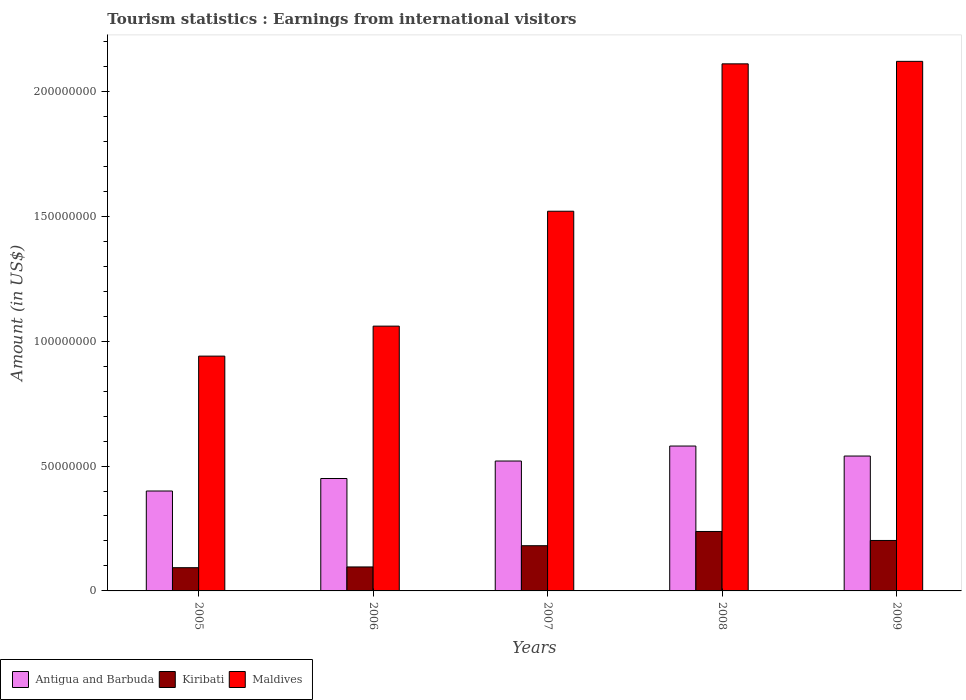How many different coloured bars are there?
Ensure brevity in your answer.  3. How many groups of bars are there?
Provide a short and direct response. 5. Are the number of bars per tick equal to the number of legend labels?
Make the answer very short. Yes. What is the label of the 1st group of bars from the left?
Your answer should be compact. 2005. What is the earnings from international visitors in Kiribati in 2007?
Your answer should be compact. 1.81e+07. Across all years, what is the maximum earnings from international visitors in Maldives?
Offer a terse response. 2.12e+08. Across all years, what is the minimum earnings from international visitors in Kiribati?
Ensure brevity in your answer.  9.30e+06. What is the total earnings from international visitors in Antigua and Barbuda in the graph?
Offer a very short reply. 2.49e+08. What is the difference between the earnings from international visitors in Kiribati in 2005 and that in 2007?
Make the answer very short. -8.80e+06. What is the difference between the earnings from international visitors in Maldives in 2005 and the earnings from international visitors in Antigua and Barbuda in 2006?
Your answer should be very brief. 4.90e+07. What is the average earnings from international visitors in Maldives per year?
Offer a very short reply. 1.55e+08. In the year 2008, what is the difference between the earnings from international visitors in Kiribati and earnings from international visitors in Maldives?
Your response must be concise. -1.87e+08. What is the ratio of the earnings from international visitors in Kiribati in 2005 to that in 2008?
Give a very brief answer. 0.39. What is the difference between the highest and the lowest earnings from international visitors in Maldives?
Provide a succinct answer. 1.18e+08. Is the sum of the earnings from international visitors in Kiribati in 2006 and 2007 greater than the maximum earnings from international visitors in Maldives across all years?
Ensure brevity in your answer.  No. What does the 1st bar from the left in 2005 represents?
Offer a terse response. Antigua and Barbuda. What does the 1st bar from the right in 2009 represents?
Provide a succinct answer. Maldives. Is it the case that in every year, the sum of the earnings from international visitors in Maldives and earnings from international visitors in Kiribati is greater than the earnings from international visitors in Antigua and Barbuda?
Give a very brief answer. Yes. Are all the bars in the graph horizontal?
Offer a terse response. No. What is the difference between two consecutive major ticks on the Y-axis?
Offer a very short reply. 5.00e+07. Where does the legend appear in the graph?
Offer a terse response. Bottom left. How many legend labels are there?
Provide a short and direct response. 3. How are the legend labels stacked?
Offer a very short reply. Horizontal. What is the title of the graph?
Make the answer very short. Tourism statistics : Earnings from international visitors. Does "Liberia" appear as one of the legend labels in the graph?
Keep it short and to the point. No. What is the Amount (in US$) in Antigua and Barbuda in 2005?
Ensure brevity in your answer.  4.00e+07. What is the Amount (in US$) in Kiribati in 2005?
Your answer should be very brief. 9.30e+06. What is the Amount (in US$) in Maldives in 2005?
Keep it short and to the point. 9.40e+07. What is the Amount (in US$) of Antigua and Barbuda in 2006?
Provide a short and direct response. 4.50e+07. What is the Amount (in US$) of Kiribati in 2006?
Your answer should be compact. 9.60e+06. What is the Amount (in US$) of Maldives in 2006?
Your response must be concise. 1.06e+08. What is the Amount (in US$) in Antigua and Barbuda in 2007?
Provide a succinct answer. 5.20e+07. What is the Amount (in US$) in Kiribati in 2007?
Your response must be concise. 1.81e+07. What is the Amount (in US$) of Maldives in 2007?
Provide a succinct answer. 1.52e+08. What is the Amount (in US$) in Antigua and Barbuda in 2008?
Make the answer very short. 5.80e+07. What is the Amount (in US$) in Kiribati in 2008?
Offer a terse response. 2.38e+07. What is the Amount (in US$) in Maldives in 2008?
Ensure brevity in your answer.  2.11e+08. What is the Amount (in US$) in Antigua and Barbuda in 2009?
Your response must be concise. 5.40e+07. What is the Amount (in US$) in Kiribati in 2009?
Offer a very short reply. 2.02e+07. What is the Amount (in US$) in Maldives in 2009?
Make the answer very short. 2.12e+08. Across all years, what is the maximum Amount (in US$) in Antigua and Barbuda?
Offer a terse response. 5.80e+07. Across all years, what is the maximum Amount (in US$) of Kiribati?
Your answer should be compact. 2.38e+07. Across all years, what is the maximum Amount (in US$) in Maldives?
Provide a succinct answer. 2.12e+08. Across all years, what is the minimum Amount (in US$) in Antigua and Barbuda?
Your answer should be compact. 4.00e+07. Across all years, what is the minimum Amount (in US$) in Kiribati?
Your answer should be compact. 9.30e+06. Across all years, what is the minimum Amount (in US$) of Maldives?
Provide a short and direct response. 9.40e+07. What is the total Amount (in US$) in Antigua and Barbuda in the graph?
Provide a short and direct response. 2.49e+08. What is the total Amount (in US$) in Kiribati in the graph?
Provide a succinct answer. 8.10e+07. What is the total Amount (in US$) in Maldives in the graph?
Your response must be concise. 7.75e+08. What is the difference between the Amount (in US$) in Antigua and Barbuda in 2005 and that in 2006?
Your answer should be very brief. -5.00e+06. What is the difference between the Amount (in US$) in Kiribati in 2005 and that in 2006?
Provide a short and direct response. -3.00e+05. What is the difference between the Amount (in US$) in Maldives in 2005 and that in 2006?
Provide a succinct answer. -1.20e+07. What is the difference between the Amount (in US$) in Antigua and Barbuda in 2005 and that in 2007?
Ensure brevity in your answer.  -1.20e+07. What is the difference between the Amount (in US$) of Kiribati in 2005 and that in 2007?
Provide a short and direct response. -8.80e+06. What is the difference between the Amount (in US$) in Maldives in 2005 and that in 2007?
Offer a terse response. -5.80e+07. What is the difference between the Amount (in US$) of Antigua and Barbuda in 2005 and that in 2008?
Your answer should be compact. -1.80e+07. What is the difference between the Amount (in US$) in Kiribati in 2005 and that in 2008?
Provide a succinct answer. -1.45e+07. What is the difference between the Amount (in US$) of Maldives in 2005 and that in 2008?
Your answer should be very brief. -1.17e+08. What is the difference between the Amount (in US$) in Antigua and Barbuda in 2005 and that in 2009?
Give a very brief answer. -1.40e+07. What is the difference between the Amount (in US$) of Kiribati in 2005 and that in 2009?
Make the answer very short. -1.09e+07. What is the difference between the Amount (in US$) of Maldives in 2005 and that in 2009?
Your response must be concise. -1.18e+08. What is the difference between the Amount (in US$) in Antigua and Barbuda in 2006 and that in 2007?
Ensure brevity in your answer.  -7.00e+06. What is the difference between the Amount (in US$) in Kiribati in 2006 and that in 2007?
Your answer should be compact. -8.50e+06. What is the difference between the Amount (in US$) of Maldives in 2006 and that in 2007?
Make the answer very short. -4.60e+07. What is the difference between the Amount (in US$) in Antigua and Barbuda in 2006 and that in 2008?
Your response must be concise. -1.30e+07. What is the difference between the Amount (in US$) in Kiribati in 2006 and that in 2008?
Ensure brevity in your answer.  -1.42e+07. What is the difference between the Amount (in US$) of Maldives in 2006 and that in 2008?
Your answer should be very brief. -1.05e+08. What is the difference between the Amount (in US$) of Antigua and Barbuda in 2006 and that in 2009?
Provide a short and direct response. -9.00e+06. What is the difference between the Amount (in US$) of Kiribati in 2006 and that in 2009?
Make the answer very short. -1.06e+07. What is the difference between the Amount (in US$) of Maldives in 2006 and that in 2009?
Provide a succinct answer. -1.06e+08. What is the difference between the Amount (in US$) in Antigua and Barbuda in 2007 and that in 2008?
Provide a succinct answer. -6.00e+06. What is the difference between the Amount (in US$) of Kiribati in 2007 and that in 2008?
Keep it short and to the point. -5.70e+06. What is the difference between the Amount (in US$) of Maldives in 2007 and that in 2008?
Keep it short and to the point. -5.90e+07. What is the difference between the Amount (in US$) in Kiribati in 2007 and that in 2009?
Your answer should be very brief. -2.10e+06. What is the difference between the Amount (in US$) of Maldives in 2007 and that in 2009?
Provide a short and direct response. -6.00e+07. What is the difference between the Amount (in US$) in Antigua and Barbuda in 2008 and that in 2009?
Your answer should be compact. 4.00e+06. What is the difference between the Amount (in US$) in Kiribati in 2008 and that in 2009?
Your response must be concise. 3.60e+06. What is the difference between the Amount (in US$) of Antigua and Barbuda in 2005 and the Amount (in US$) of Kiribati in 2006?
Your response must be concise. 3.04e+07. What is the difference between the Amount (in US$) of Antigua and Barbuda in 2005 and the Amount (in US$) of Maldives in 2006?
Your answer should be very brief. -6.60e+07. What is the difference between the Amount (in US$) of Kiribati in 2005 and the Amount (in US$) of Maldives in 2006?
Your response must be concise. -9.67e+07. What is the difference between the Amount (in US$) in Antigua and Barbuda in 2005 and the Amount (in US$) in Kiribati in 2007?
Provide a succinct answer. 2.19e+07. What is the difference between the Amount (in US$) in Antigua and Barbuda in 2005 and the Amount (in US$) in Maldives in 2007?
Keep it short and to the point. -1.12e+08. What is the difference between the Amount (in US$) in Kiribati in 2005 and the Amount (in US$) in Maldives in 2007?
Make the answer very short. -1.43e+08. What is the difference between the Amount (in US$) in Antigua and Barbuda in 2005 and the Amount (in US$) in Kiribati in 2008?
Offer a terse response. 1.62e+07. What is the difference between the Amount (in US$) in Antigua and Barbuda in 2005 and the Amount (in US$) in Maldives in 2008?
Provide a short and direct response. -1.71e+08. What is the difference between the Amount (in US$) in Kiribati in 2005 and the Amount (in US$) in Maldives in 2008?
Make the answer very short. -2.02e+08. What is the difference between the Amount (in US$) in Antigua and Barbuda in 2005 and the Amount (in US$) in Kiribati in 2009?
Offer a terse response. 1.98e+07. What is the difference between the Amount (in US$) in Antigua and Barbuda in 2005 and the Amount (in US$) in Maldives in 2009?
Keep it short and to the point. -1.72e+08. What is the difference between the Amount (in US$) in Kiribati in 2005 and the Amount (in US$) in Maldives in 2009?
Your answer should be compact. -2.03e+08. What is the difference between the Amount (in US$) of Antigua and Barbuda in 2006 and the Amount (in US$) of Kiribati in 2007?
Make the answer very short. 2.69e+07. What is the difference between the Amount (in US$) in Antigua and Barbuda in 2006 and the Amount (in US$) in Maldives in 2007?
Your answer should be very brief. -1.07e+08. What is the difference between the Amount (in US$) of Kiribati in 2006 and the Amount (in US$) of Maldives in 2007?
Make the answer very short. -1.42e+08. What is the difference between the Amount (in US$) of Antigua and Barbuda in 2006 and the Amount (in US$) of Kiribati in 2008?
Your answer should be very brief. 2.12e+07. What is the difference between the Amount (in US$) of Antigua and Barbuda in 2006 and the Amount (in US$) of Maldives in 2008?
Give a very brief answer. -1.66e+08. What is the difference between the Amount (in US$) in Kiribati in 2006 and the Amount (in US$) in Maldives in 2008?
Make the answer very short. -2.01e+08. What is the difference between the Amount (in US$) in Antigua and Barbuda in 2006 and the Amount (in US$) in Kiribati in 2009?
Your answer should be very brief. 2.48e+07. What is the difference between the Amount (in US$) of Antigua and Barbuda in 2006 and the Amount (in US$) of Maldives in 2009?
Make the answer very short. -1.67e+08. What is the difference between the Amount (in US$) of Kiribati in 2006 and the Amount (in US$) of Maldives in 2009?
Provide a short and direct response. -2.02e+08. What is the difference between the Amount (in US$) in Antigua and Barbuda in 2007 and the Amount (in US$) in Kiribati in 2008?
Offer a terse response. 2.82e+07. What is the difference between the Amount (in US$) of Antigua and Barbuda in 2007 and the Amount (in US$) of Maldives in 2008?
Your answer should be very brief. -1.59e+08. What is the difference between the Amount (in US$) in Kiribati in 2007 and the Amount (in US$) in Maldives in 2008?
Offer a terse response. -1.93e+08. What is the difference between the Amount (in US$) in Antigua and Barbuda in 2007 and the Amount (in US$) in Kiribati in 2009?
Give a very brief answer. 3.18e+07. What is the difference between the Amount (in US$) in Antigua and Barbuda in 2007 and the Amount (in US$) in Maldives in 2009?
Give a very brief answer. -1.60e+08. What is the difference between the Amount (in US$) of Kiribati in 2007 and the Amount (in US$) of Maldives in 2009?
Offer a terse response. -1.94e+08. What is the difference between the Amount (in US$) of Antigua and Barbuda in 2008 and the Amount (in US$) of Kiribati in 2009?
Offer a terse response. 3.78e+07. What is the difference between the Amount (in US$) in Antigua and Barbuda in 2008 and the Amount (in US$) in Maldives in 2009?
Offer a very short reply. -1.54e+08. What is the difference between the Amount (in US$) in Kiribati in 2008 and the Amount (in US$) in Maldives in 2009?
Your answer should be compact. -1.88e+08. What is the average Amount (in US$) of Antigua and Barbuda per year?
Your answer should be compact. 4.98e+07. What is the average Amount (in US$) in Kiribati per year?
Your answer should be compact. 1.62e+07. What is the average Amount (in US$) of Maldives per year?
Offer a very short reply. 1.55e+08. In the year 2005, what is the difference between the Amount (in US$) in Antigua and Barbuda and Amount (in US$) in Kiribati?
Keep it short and to the point. 3.07e+07. In the year 2005, what is the difference between the Amount (in US$) of Antigua and Barbuda and Amount (in US$) of Maldives?
Keep it short and to the point. -5.40e+07. In the year 2005, what is the difference between the Amount (in US$) of Kiribati and Amount (in US$) of Maldives?
Provide a succinct answer. -8.47e+07. In the year 2006, what is the difference between the Amount (in US$) in Antigua and Barbuda and Amount (in US$) in Kiribati?
Ensure brevity in your answer.  3.54e+07. In the year 2006, what is the difference between the Amount (in US$) of Antigua and Barbuda and Amount (in US$) of Maldives?
Your answer should be compact. -6.10e+07. In the year 2006, what is the difference between the Amount (in US$) of Kiribati and Amount (in US$) of Maldives?
Keep it short and to the point. -9.64e+07. In the year 2007, what is the difference between the Amount (in US$) in Antigua and Barbuda and Amount (in US$) in Kiribati?
Your response must be concise. 3.39e+07. In the year 2007, what is the difference between the Amount (in US$) of Antigua and Barbuda and Amount (in US$) of Maldives?
Provide a succinct answer. -1.00e+08. In the year 2007, what is the difference between the Amount (in US$) in Kiribati and Amount (in US$) in Maldives?
Ensure brevity in your answer.  -1.34e+08. In the year 2008, what is the difference between the Amount (in US$) in Antigua and Barbuda and Amount (in US$) in Kiribati?
Provide a succinct answer. 3.42e+07. In the year 2008, what is the difference between the Amount (in US$) in Antigua and Barbuda and Amount (in US$) in Maldives?
Make the answer very short. -1.53e+08. In the year 2008, what is the difference between the Amount (in US$) of Kiribati and Amount (in US$) of Maldives?
Make the answer very short. -1.87e+08. In the year 2009, what is the difference between the Amount (in US$) of Antigua and Barbuda and Amount (in US$) of Kiribati?
Ensure brevity in your answer.  3.38e+07. In the year 2009, what is the difference between the Amount (in US$) in Antigua and Barbuda and Amount (in US$) in Maldives?
Give a very brief answer. -1.58e+08. In the year 2009, what is the difference between the Amount (in US$) in Kiribati and Amount (in US$) in Maldives?
Offer a terse response. -1.92e+08. What is the ratio of the Amount (in US$) of Antigua and Barbuda in 2005 to that in 2006?
Offer a very short reply. 0.89. What is the ratio of the Amount (in US$) in Kiribati in 2005 to that in 2006?
Provide a short and direct response. 0.97. What is the ratio of the Amount (in US$) in Maldives in 2005 to that in 2006?
Provide a succinct answer. 0.89. What is the ratio of the Amount (in US$) in Antigua and Barbuda in 2005 to that in 2007?
Provide a succinct answer. 0.77. What is the ratio of the Amount (in US$) of Kiribati in 2005 to that in 2007?
Offer a very short reply. 0.51. What is the ratio of the Amount (in US$) of Maldives in 2005 to that in 2007?
Offer a terse response. 0.62. What is the ratio of the Amount (in US$) in Antigua and Barbuda in 2005 to that in 2008?
Your response must be concise. 0.69. What is the ratio of the Amount (in US$) in Kiribati in 2005 to that in 2008?
Ensure brevity in your answer.  0.39. What is the ratio of the Amount (in US$) in Maldives in 2005 to that in 2008?
Your answer should be compact. 0.45. What is the ratio of the Amount (in US$) in Antigua and Barbuda in 2005 to that in 2009?
Your answer should be very brief. 0.74. What is the ratio of the Amount (in US$) in Kiribati in 2005 to that in 2009?
Offer a terse response. 0.46. What is the ratio of the Amount (in US$) in Maldives in 2005 to that in 2009?
Your answer should be very brief. 0.44. What is the ratio of the Amount (in US$) of Antigua and Barbuda in 2006 to that in 2007?
Make the answer very short. 0.87. What is the ratio of the Amount (in US$) in Kiribati in 2006 to that in 2007?
Ensure brevity in your answer.  0.53. What is the ratio of the Amount (in US$) in Maldives in 2006 to that in 2007?
Provide a short and direct response. 0.7. What is the ratio of the Amount (in US$) in Antigua and Barbuda in 2006 to that in 2008?
Offer a terse response. 0.78. What is the ratio of the Amount (in US$) of Kiribati in 2006 to that in 2008?
Provide a succinct answer. 0.4. What is the ratio of the Amount (in US$) of Maldives in 2006 to that in 2008?
Your answer should be very brief. 0.5. What is the ratio of the Amount (in US$) of Antigua and Barbuda in 2006 to that in 2009?
Provide a short and direct response. 0.83. What is the ratio of the Amount (in US$) in Kiribati in 2006 to that in 2009?
Provide a succinct answer. 0.48. What is the ratio of the Amount (in US$) of Maldives in 2006 to that in 2009?
Make the answer very short. 0.5. What is the ratio of the Amount (in US$) in Antigua and Barbuda in 2007 to that in 2008?
Keep it short and to the point. 0.9. What is the ratio of the Amount (in US$) in Kiribati in 2007 to that in 2008?
Your response must be concise. 0.76. What is the ratio of the Amount (in US$) of Maldives in 2007 to that in 2008?
Keep it short and to the point. 0.72. What is the ratio of the Amount (in US$) in Antigua and Barbuda in 2007 to that in 2009?
Your response must be concise. 0.96. What is the ratio of the Amount (in US$) of Kiribati in 2007 to that in 2009?
Offer a terse response. 0.9. What is the ratio of the Amount (in US$) of Maldives in 2007 to that in 2009?
Offer a very short reply. 0.72. What is the ratio of the Amount (in US$) of Antigua and Barbuda in 2008 to that in 2009?
Your response must be concise. 1.07. What is the ratio of the Amount (in US$) in Kiribati in 2008 to that in 2009?
Your answer should be compact. 1.18. What is the difference between the highest and the second highest Amount (in US$) of Kiribati?
Your response must be concise. 3.60e+06. What is the difference between the highest and the second highest Amount (in US$) of Maldives?
Offer a very short reply. 1.00e+06. What is the difference between the highest and the lowest Amount (in US$) in Antigua and Barbuda?
Provide a short and direct response. 1.80e+07. What is the difference between the highest and the lowest Amount (in US$) of Kiribati?
Ensure brevity in your answer.  1.45e+07. What is the difference between the highest and the lowest Amount (in US$) in Maldives?
Provide a succinct answer. 1.18e+08. 